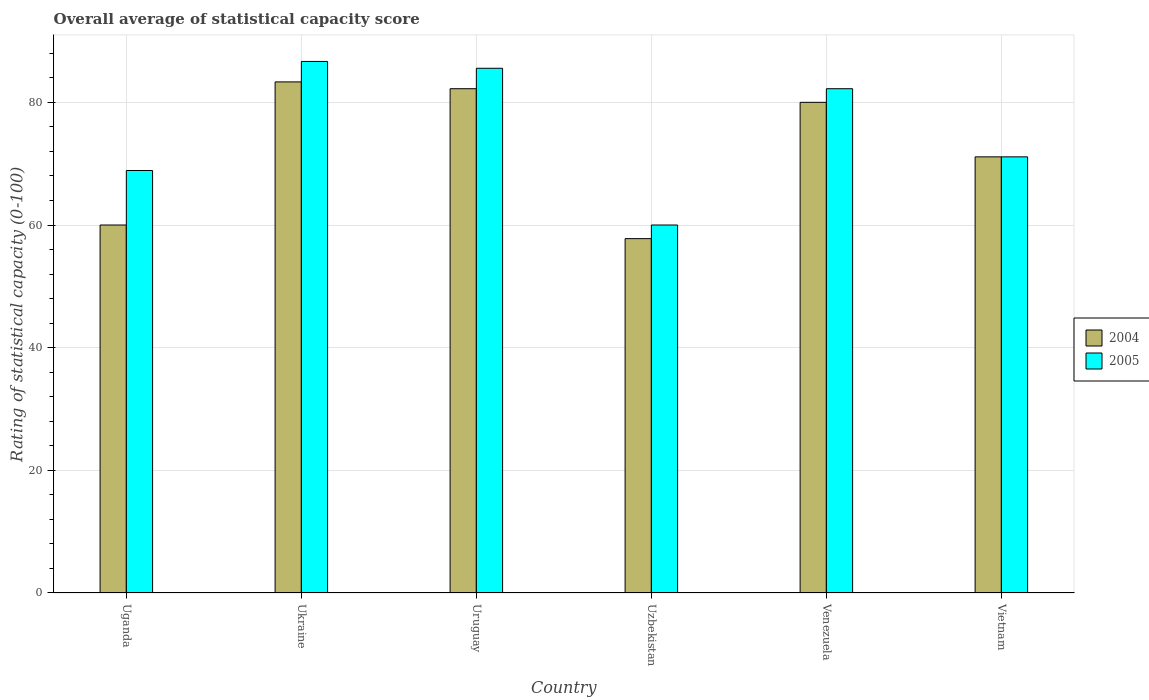How many groups of bars are there?
Offer a terse response. 6. Are the number of bars per tick equal to the number of legend labels?
Your answer should be compact. Yes. Are the number of bars on each tick of the X-axis equal?
Provide a succinct answer. Yes. How many bars are there on the 3rd tick from the left?
Provide a succinct answer. 2. What is the label of the 4th group of bars from the left?
Keep it short and to the point. Uzbekistan. In how many cases, is the number of bars for a given country not equal to the number of legend labels?
Provide a succinct answer. 0. What is the rating of statistical capacity in 2005 in Uruguay?
Make the answer very short. 85.56. Across all countries, what is the maximum rating of statistical capacity in 2004?
Offer a terse response. 83.33. Across all countries, what is the minimum rating of statistical capacity in 2004?
Your answer should be very brief. 57.78. In which country was the rating of statistical capacity in 2005 maximum?
Your answer should be compact. Ukraine. In which country was the rating of statistical capacity in 2004 minimum?
Ensure brevity in your answer.  Uzbekistan. What is the total rating of statistical capacity in 2005 in the graph?
Offer a terse response. 454.44. What is the difference between the rating of statistical capacity in 2005 in Uganda and that in Ukraine?
Your response must be concise. -17.78. What is the difference between the rating of statistical capacity in 2004 in Uruguay and the rating of statistical capacity in 2005 in Uzbekistan?
Give a very brief answer. 22.22. What is the average rating of statistical capacity in 2005 per country?
Your answer should be very brief. 75.74. What is the difference between the rating of statistical capacity of/in 2005 and rating of statistical capacity of/in 2004 in Uruguay?
Offer a very short reply. 3.33. What is the ratio of the rating of statistical capacity in 2005 in Uruguay to that in Uzbekistan?
Offer a very short reply. 1.43. Is the difference between the rating of statistical capacity in 2005 in Uruguay and Vietnam greater than the difference between the rating of statistical capacity in 2004 in Uruguay and Vietnam?
Ensure brevity in your answer.  Yes. What is the difference between the highest and the second highest rating of statistical capacity in 2004?
Provide a short and direct response. -2.22. What is the difference between the highest and the lowest rating of statistical capacity in 2004?
Offer a very short reply. 25.56. In how many countries, is the rating of statistical capacity in 2004 greater than the average rating of statistical capacity in 2004 taken over all countries?
Give a very brief answer. 3. Is the sum of the rating of statistical capacity in 2004 in Uruguay and Vietnam greater than the maximum rating of statistical capacity in 2005 across all countries?
Offer a terse response. Yes. How many countries are there in the graph?
Keep it short and to the point. 6. What is the difference between two consecutive major ticks on the Y-axis?
Keep it short and to the point. 20. Does the graph contain any zero values?
Your answer should be compact. No. Where does the legend appear in the graph?
Your answer should be very brief. Center right. What is the title of the graph?
Your answer should be compact. Overall average of statistical capacity score. Does "2006" appear as one of the legend labels in the graph?
Provide a short and direct response. No. What is the label or title of the Y-axis?
Your response must be concise. Rating of statistical capacity (0-100). What is the Rating of statistical capacity (0-100) of 2005 in Uganda?
Offer a very short reply. 68.89. What is the Rating of statistical capacity (0-100) in 2004 in Ukraine?
Your answer should be very brief. 83.33. What is the Rating of statistical capacity (0-100) of 2005 in Ukraine?
Provide a short and direct response. 86.67. What is the Rating of statistical capacity (0-100) in 2004 in Uruguay?
Your answer should be compact. 82.22. What is the Rating of statistical capacity (0-100) of 2005 in Uruguay?
Provide a short and direct response. 85.56. What is the Rating of statistical capacity (0-100) in 2004 in Uzbekistan?
Provide a succinct answer. 57.78. What is the Rating of statistical capacity (0-100) in 2004 in Venezuela?
Provide a succinct answer. 80. What is the Rating of statistical capacity (0-100) in 2005 in Venezuela?
Give a very brief answer. 82.22. What is the Rating of statistical capacity (0-100) in 2004 in Vietnam?
Make the answer very short. 71.11. What is the Rating of statistical capacity (0-100) of 2005 in Vietnam?
Ensure brevity in your answer.  71.11. Across all countries, what is the maximum Rating of statistical capacity (0-100) of 2004?
Your answer should be compact. 83.33. Across all countries, what is the maximum Rating of statistical capacity (0-100) in 2005?
Your answer should be very brief. 86.67. Across all countries, what is the minimum Rating of statistical capacity (0-100) of 2004?
Your answer should be compact. 57.78. Across all countries, what is the minimum Rating of statistical capacity (0-100) in 2005?
Provide a succinct answer. 60. What is the total Rating of statistical capacity (0-100) in 2004 in the graph?
Your answer should be very brief. 434.44. What is the total Rating of statistical capacity (0-100) of 2005 in the graph?
Offer a very short reply. 454.44. What is the difference between the Rating of statistical capacity (0-100) of 2004 in Uganda and that in Ukraine?
Give a very brief answer. -23.33. What is the difference between the Rating of statistical capacity (0-100) of 2005 in Uganda and that in Ukraine?
Make the answer very short. -17.78. What is the difference between the Rating of statistical capacity (0-100) of 2004 in Uganda and that in Uruguay?
Offer a terse response. -22.22. What is the difference between the Rating of statistical capacity (0-100) in 2005 in Uganda and that in Uruguay?
Offer a terse response. -16.67. What is the difference between the Rating of statistical capacity (0-100) in 2004 in Uganda and that in Uzbekistan?
Provide a short and direct response. 2.22. What is the difference between the Rating of statistical capacity (0-100) of 2005 in Uganda and that in Uzbekistan?
Your answer should be very brief. 8.89. What is the difference between the Rating of statistical capacity (0-100) in 2005 in Uganda and that in Venezuela?
Provide a short and direct response. -13.33. What is the difference between the Rating of statistical capacity (0-100) of 2004 in Uganda and that in Vietnam?
Provide a short and direct response. -11.11. What is the difference between the Rating of statistical capacity (0-100) in 2005 in Uganda and that in Vietnam?
Ensure brevity in your answer.  -2.22. What is the difference between the Rating of statistical capacity (0-100) of 2004 in Ukraine and that in Uruguay?
Provide a short and direct response. 1.11. What is the difference between the Rating of statistical capacity (0-100) in 2005 in Ukraine and that in Uruguay?
Offer a terse response. 1.11. What is the difference between the Rating of statistical capacity (0-100) in 2004 in Ukraine and that in Uzbekistan?
Offer a terse response. 25.56. What is the difference between the Rating of statistical capacity (0-100) in 2005 in Ukraine and that in Uzbekistan?
Make the answer very short. 26.67. What is the difference between the Rating of statistical capacity (0-100) of 2005 in Ukraine and that in Venezuela?
Provide a short and direct response. 4.44. What is the difference between the Rating of statistical capacity (0-100) in 2004 in Ukraine and that in Vietnam?
Offer a very short reply. 12.22. What is the difference between the Rating of statistical capacity (0-100) of 2005 in Ukraine and that in Vietnam?
Ensure brevity in your answer.  15.56. What is the difference between the Rating of statistical capacity (0-100) of 2004 in Uruguay and that in Uzbekistan?
Your answer should be compact. 24.44. What is the difference between the Rating of statistical capacity (0-100) of 2005 in Uruguay and that in Uzbekistan?
Offer a terse response. 25.56. What is the difference between the Rating of statistical capacity (0-100) in 2004 in Uruguay and that in Venezuela?
Your response must be concise. 2.22. What is the difference between the Rating of statistical capacity (0-100) in 2005 in Uruguay and that in Venezuela?
Give a very brief answer. 3.33. What is the difference between the Rating of statistical capacity (0-100) in 2004 in Uruguay and that in Vietnam?
Your response must be concise. 11.11. What is the difference between the Rating of statistical capacity (0-100) of 2005 in Uruguay and that in Vietnam?
Offer a very short reply. 14.44. What is the difference between the Rating of statistical capacity (0-100) of 2004 in Uzbekistan and that in Venezuela?
Ensure brevity in your answer.  -22.22. What is the difference between the Rating of statistical capacity (0-100) in 2005 in Uzbekistan and that in Venezuela?
Ensure brevity in your answer.  -22.22. What is the difference between the Rating of statistical capacity (0-100) in 2004 in Uzbekistan and that in Vietnam?
Provide a short and direct response. -13.33. What is the difference between the Rating of statistical capacity (0-100) of 2005 in Uzbekistan and that in Vietnam?
Your answer should be very brief. -11.11. What is the difference between the Rating of statistical capacity (0-100) of 2004 in Venezuela and that in Vietnam?
Make the answer very short. 8.89. What is the difference between the Rating of statistical capacity (0-100) in 2005 in Venezuela and that in Vietnam?
Ensure brevity in your answer.  11.11. What is the difference between the Rating of statistical capacity (0-100) of 2004 in Uganda and the Rating of statistical capacity (0-100) of 2005 in Ukraine?
Your answer should be compact. -26.67. What is the difference between the Rating of statistical capacity (0-100) of 2004 in Uganda and the Rating of statistical capacity (0-100) of 2005 in Uruguay?
Make the answer very short. -25.56. What is the difference between the Rating of statistical capacity (0-100) in 2004 in Uganda and the Rating of statistical capacity (0-100) in 2005 in Venezuela?
Offer a very short reply. -22.22. What is the difference between the Rating of statistical capacity (0-100) in 2004 in Uganda and the Rating of statistical capacity (0-100) in 2005 in Vietnam?
Your answer should be compact. -11.11. What is the difference between the Rating of statistical capacity (0-100) in 2004 in Ukraine and the Rating of statistical capacity (0-100) in 2005 in Uruguay?
Give a very brief answer. -2.22. What is the difference between the Rating of statistical capacity (0-100) in 2004 in Ukraine and the Rating of statistical capacity (0-100) in 2005 in Uzbekistan?
Your response must be concise. 23.33. What is the difference between the Rating of statistical capacity (0-100) of 2004 in Ukraine and the Rating of statistical capacity (0-100) of 2005 in Venezuela?
Your answer should be very brief. 1.11. What is the difference between the Rating of statistical capacity (0-100) of 2004 in Ukraine and the Rating of statistical capacity (0-100) of 2005 in Vietnam?
Offer a terse response. 12.22. What is the difference between the Rating of statistical capacity (0-100) of 2004 in Uruguay and the Rating of statistical capacity (0-100) of 2005 in Uzbekistan?
Make the answer very short. 22.22. What is the difference between the Rating of statistical capacity (0-100) in 2004 in Uruguay and the Rating of statistical capacity (0-100) in 2005 in Vietnam?
Keep it short and to the point. 11.11. What is the difference between the Rating of statistical capacity (0-100) of 2004 in Uzbekistan and the Rating of statistical capacity (0-100) of 2005 in Venezuela?
Provide a short and direct response. -24.44. What is the difference between the Rating of statistical capacity (0-100) in 2004 in Uzbekistan and the Rating of statistical capacity (0-100) in 2005 in Vietnam?
Provide a succinct answer. -13.33. What is the difference between the Rating of statistical capacity (0-100) in 2004 in Venezuela and the Rating of statistical capacity (0-100) in 2005 in Vietnam?
Your response must be concise. 8.89. What is the average Rating of statistical capacity (0-100) of 2004 per country?
Offer a very short reply. 72.41. What is the average Rating of statistical capacity (0-100) of 2005 per country?
Offer a very short reply. 75.74. What is the difference between the Rating of statistical capacity (0-100) of 2004 and Rating of statistical capacity (0-100) of 2005 in Uganda?
Your response must be concise. -8.89. What is the difference between the Rating of statistical capacity (0-100) in 2004 and Rating of statistical capacity (0-100) in 2005 in Uzbekistan?
Provide a succinct answer. -2.22. What is the difference between the Rating of statistical capacity (0-100) in 2004 and Rating of statistical capacity (0-100) in 2005 in Venezuela?
Your answer should be very brief. -2.22. What is the ratio of the Rating of statistical capacity (0-100) in 2004 in Uganda to that in Ukraine?
Offer a very short reply. 0.72. What is the ratio of the Rating of statistical capacity (0-100) of 2005 in Uganda to that in Ukraine?
Provide a succinct answer. 0.79. What is the ratio of the Rating of statistical capacity (0-100) of 2004 in Uganda to that in Uruguay?
Keep it short and to the point. 0.73. What is the ratio of the Rating of statistical capacity (0-100) in 2005 in Uganda to that in Uruguay?
Ensure brevity in your answer.  0.81. What is the ratio of the Rating of statistical capacity (0-100) of 2005 in Uganda to that in Uzbekistan?
Your response must be concise. 1.15. What is the ratio of the Rating of statistical capacity (0-100) in 2004 in Uganda to that in Venezuela?
Offer a terse response. 0.75. What is the ratio of the Rating of statistical capacity (0-100) in 2005 in Uganda to that in Venezuela?
Keep it short and to the point. 0.84. What is the ratio of the Rating of statistical capacity (0-100) of 2004 in Uganda to that in Vietnam?
Keep it short and to the point. 0.84. What is the ratio of the Rating of statistical capacity (0-100) of 2005 in Uganda to that in Vietnam?
Offer a very short reply. 0.97. What is the ratio of the Rating of statistical capacity (0-100) of 2004 in Ukraine to that in Uruguay?
Ensure brevity in your answer.  1.01. What is the ratio of the Rating of statistical capacity (0-100) of 2005 in Ukraine to that in Uruguay?
Offer a very short reply. 1.01. What is the ratio of the Rating of statistical capacity (0-100) in 2004 in Ukraine to that in Uzbekistan?
Your response must be concise. 1.44. What is the ratio of the Rating of statistical capacity (0-100) in 2005 in Ukraine to that in Uzbekistan?
Your answer should be very brief. 1.44. What is the ratio of the Rating of statistical capacity (0-100) of 2004 in Ukraine to that in Venezuela?
Your answer should be compact. 1.04. What is the ratio of the Rating of statistical capacity (0-100) in 2005 in Ukraine to that in Venezuela?
Offer a very short reply. 1.05. What is the ratio of the Rating of statistical capacity (0-100) in 2004 in Ukraine to that in Vietnam?
Give a very brief answer. 1.17. What is the ratio of the Rating of statistical capacity (0-100) in 2005 in Ukraine to that in Vietnam?
Give a very brief answer. 1.22. What is the ratio of the Rating of statistical capacity (0-100) of 2004 in Uruguay to that in Uzbekistan?
Your response must be concise. 1.42. What is the ratio of the Rating of statistical capacity (0-100) of 2005 in Uruguay to that in Uzbekistan?
Offer a terse response. 1.43. What is the ratio of the Rating of statistical capacity (0-100) in 2004 in Uruguay to that in Venezuela?
Provide a succinct answer. 1.03. What is the ratio of the Rating of statistical capacity (0-100) of 2005 in Uruguay to that in Venezuela?
Your response must be concise. 1.04. What is the ratio of the Rating of statistical capacity (0-100) in 2004 in Uruguay to that in Vietnam?
Ensure brevity in your answer.  1.16. What is the ratio of the Rating of statistical capacity (0-100) in 2005 in Uruguay to that in Vietnam?
Offer a terse response. 1.2. What is the ratio of the Rating of statistical capacity (0-100) in 2004 in Uzbekistan to that in Venezuela?
Your answer should be compact. 0.72. What is the ratio of the Rating of statistical capacity (0-100) in 2005 in Uzbekistan to that in Venezuela?
Ensure brevity in your answer.  0.73. What is the ratio of the Rating of statistical capacity (0-100) of 2004 in Uzbekistan to that in Vietnam?
Offer a very short reply. 0.81. What is the ratio of the Rating of statistical capacity (0-100) of 2005 in Uzbekistan to that in Vietnam?
Offer a terse response. 0.84. What is the ratio of the Rating of statistical capacity (0-100) in 2005 in Venezuela to that in Vietnam?
Ensure brevity in your answer.  1.16. What is the difference between the highest and the second highest Rating of statistical capacity (0-100) of 2004?
Keep it short and to the point. 1.11. What is the difference between the highest and the lowest Rating of statistical capacity (0-100) of 2004?
Make the answer very short. 25.56. What is the difference between the highest and the lowest Rating of statistical capacity (0-100) in 2005?
Provide a short and direct response. 26.67. 